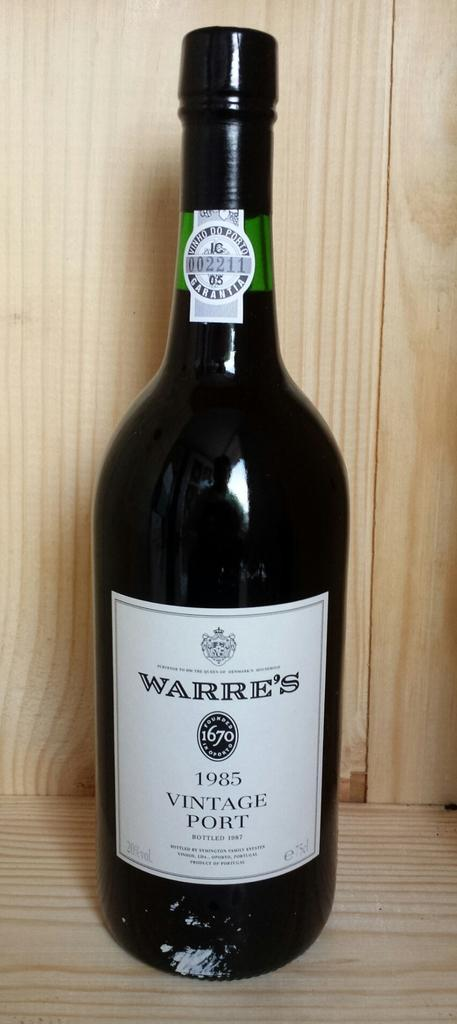<image>
Give a short and clear explanation of the subsequent image. A bottle of Warre's 1985 Vintage Port stands on a shelf. 